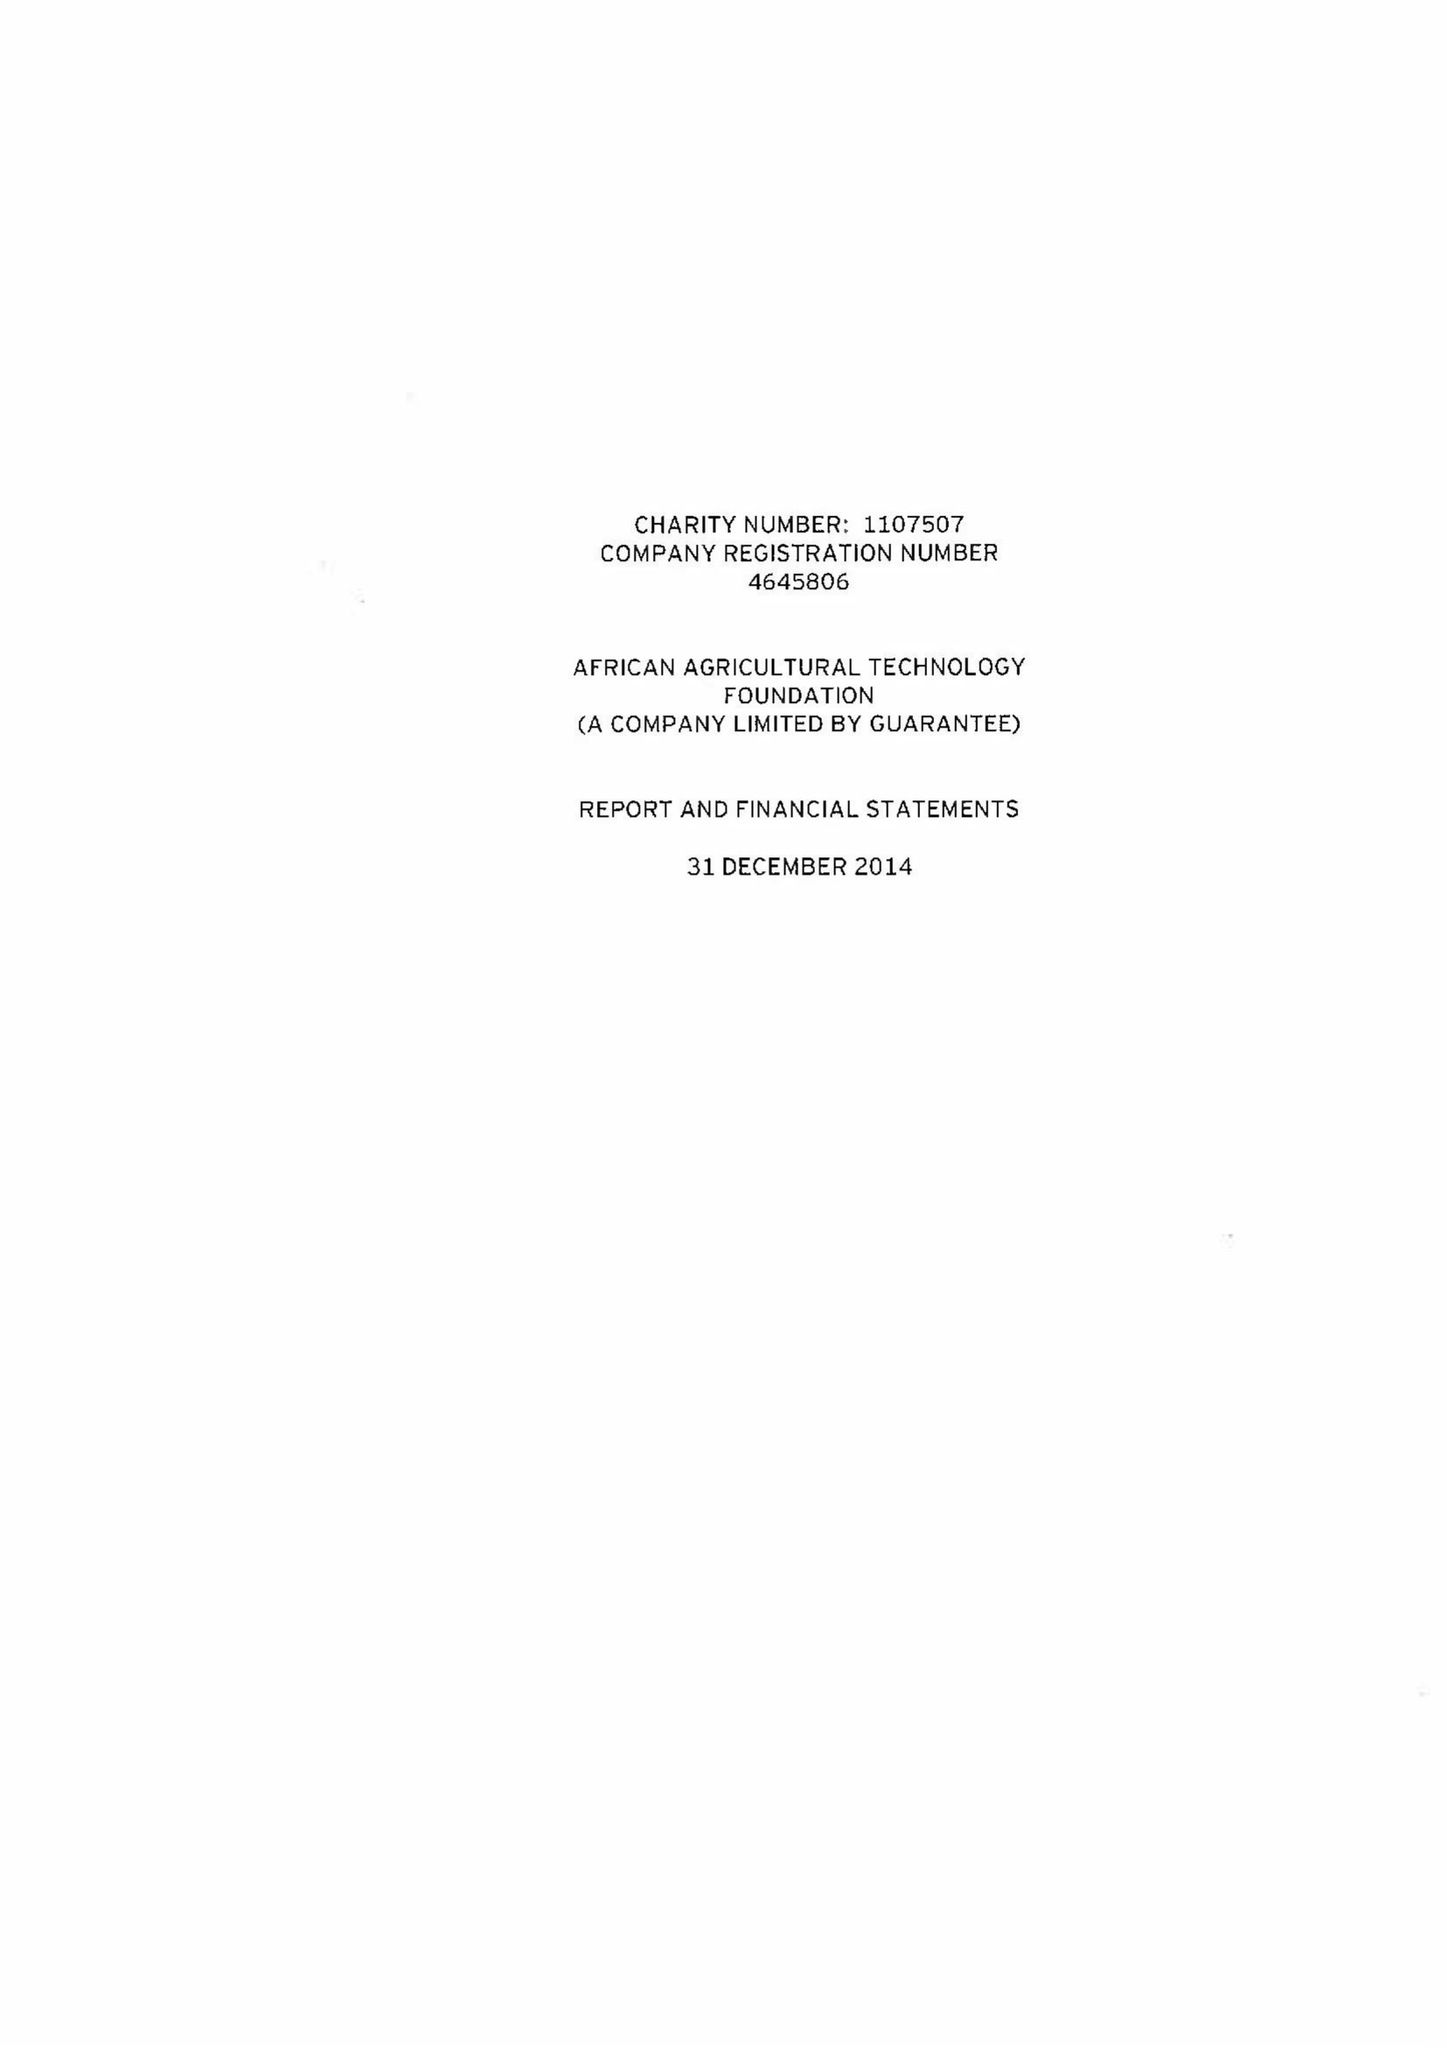What is the value for the address__post_town?
Answer the question using a single word or phrase. LONDON 